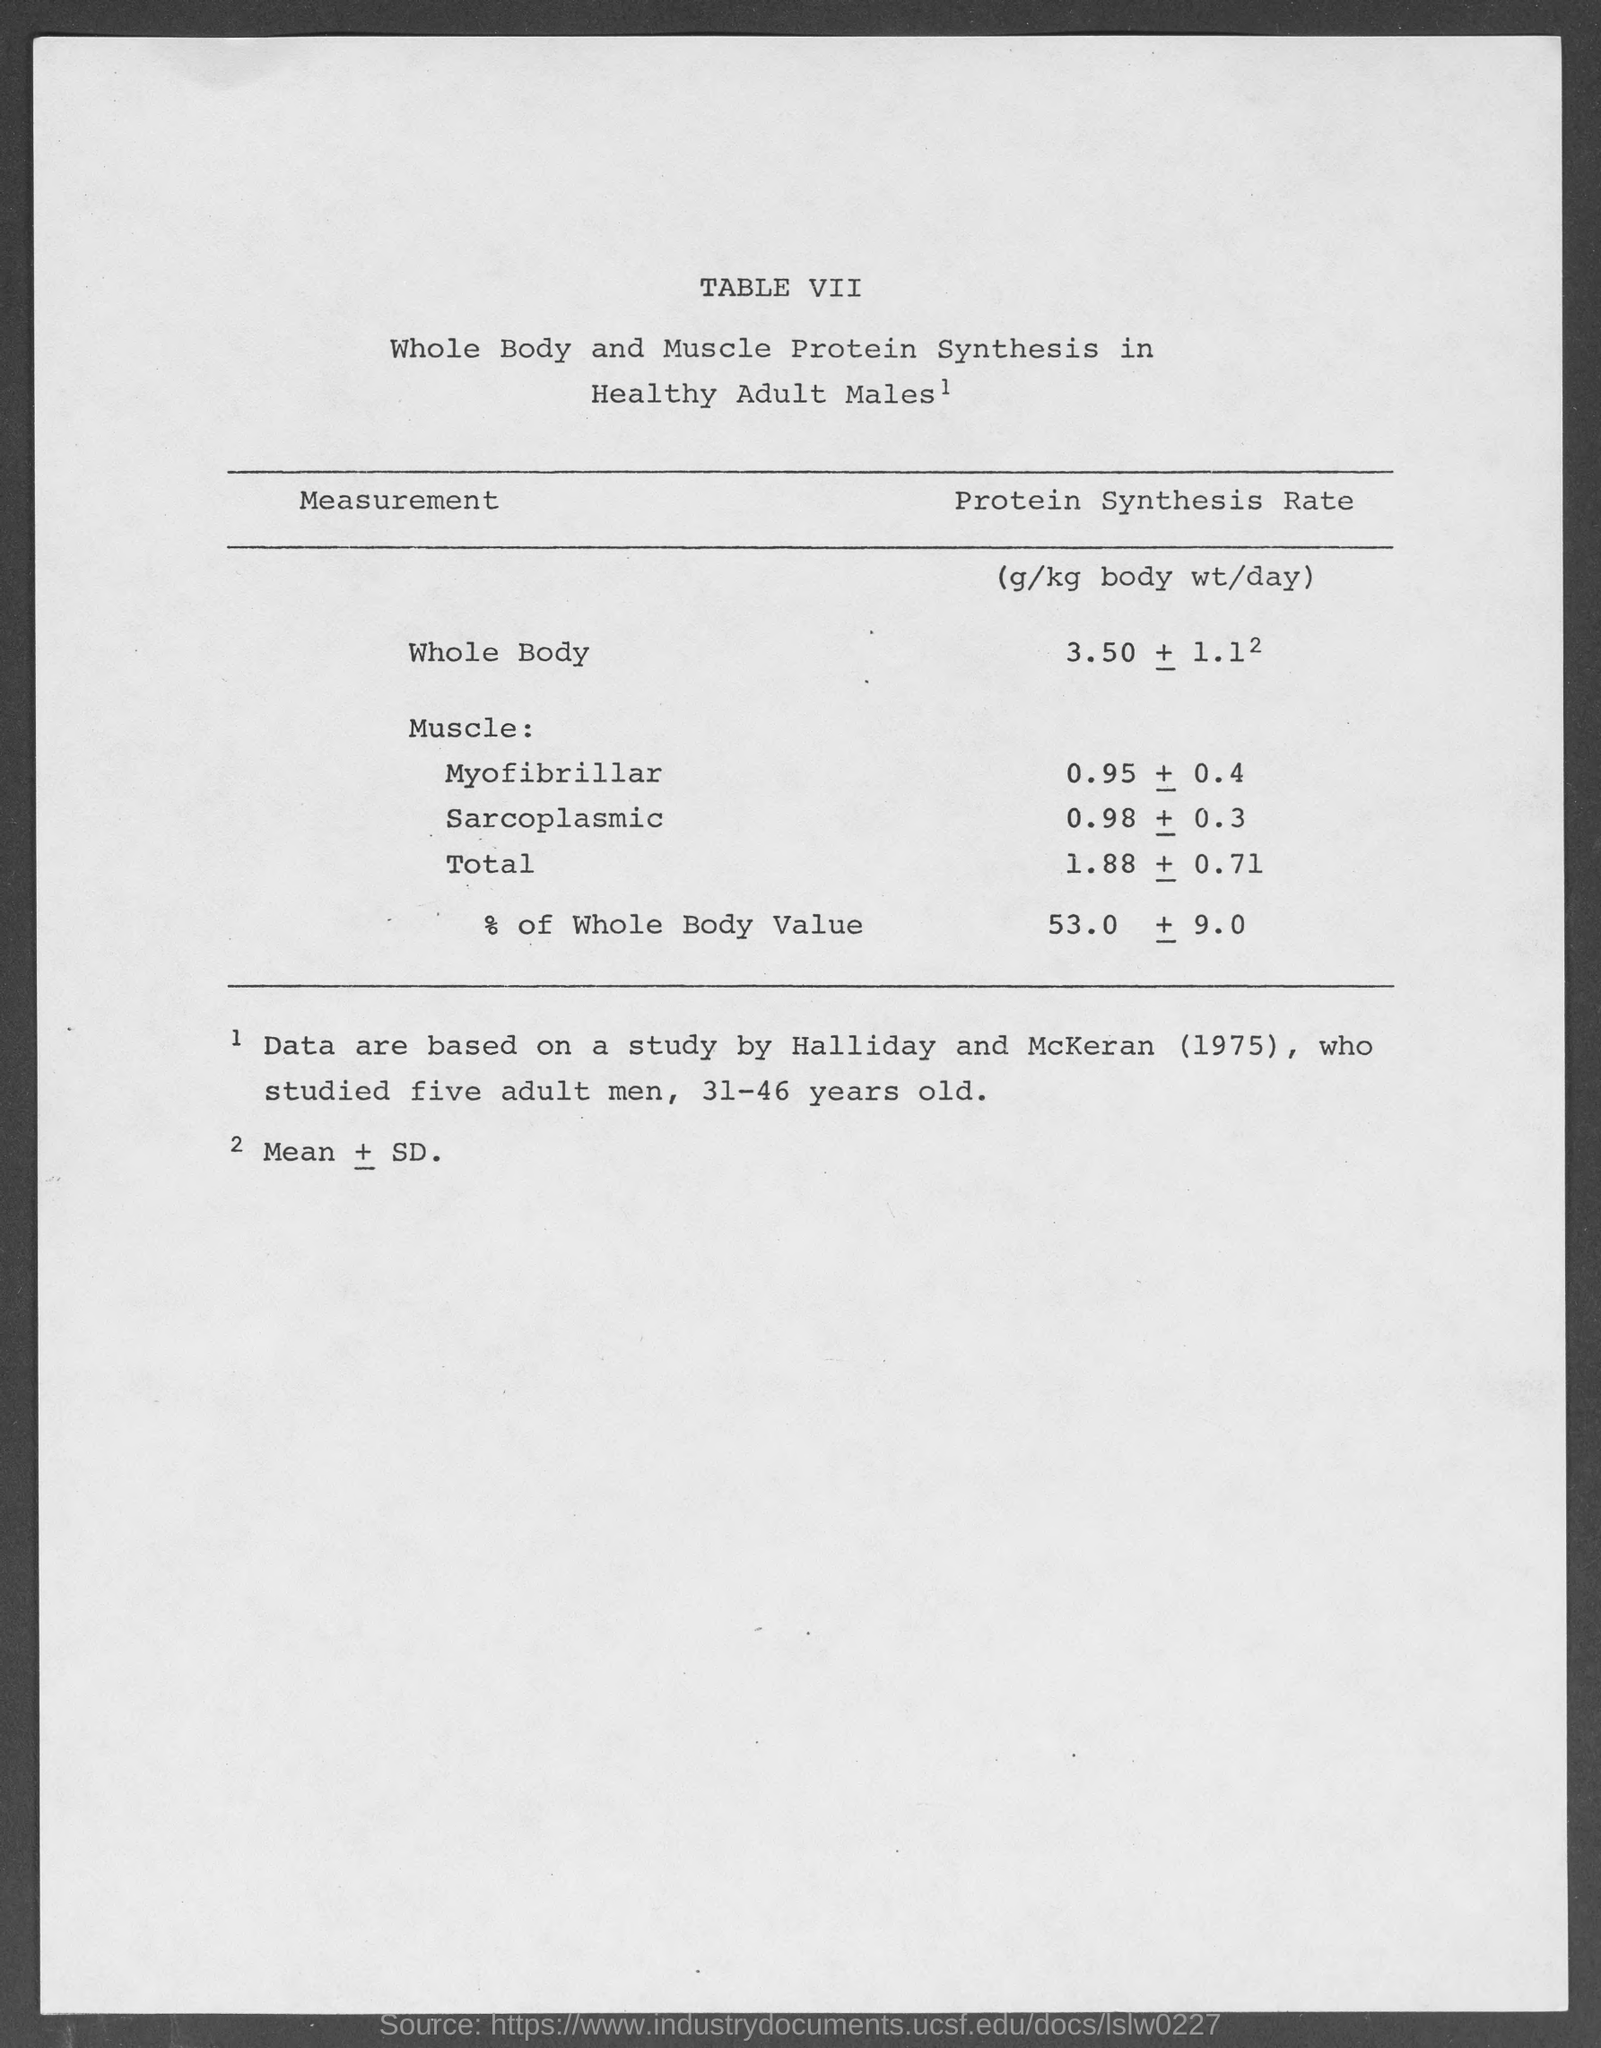Give some essential details in this illustration. The table number is VII. 